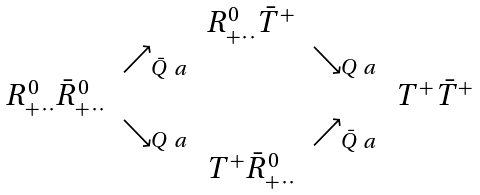Convert formula to latex. <formula><loc_0><loc_0><loc_500><loc_500>\begin{array} { c c c c c c c c c } & & & & R ^ { 0 } _ { + \, \cdot \, \cdot } \bar { T } ^ { + } & & & & \\ & & & \nearrow _ { \bar { Q } _ { \ } a } & & \searrow _ { Q _ { \ } a } & & \\ & & R ^ { 0 } _ { + \, \cdot \, \cdot } \bar { R } ^ { 0 } _ { + \, \cdot \, \cdot } & & & & T ^ { + } \bar { T } ^ { + } & & \\ & & & \searrow _ { Q _ { \ } a } & & \nearrow _ { \bar { Q } _ { \ } a } & & & \\ & & & & T ^ { + } \bar { R } ^ { 0 } _ { + \, \cdot \, \cdot } & & & & \\ \end{array}</formula> 